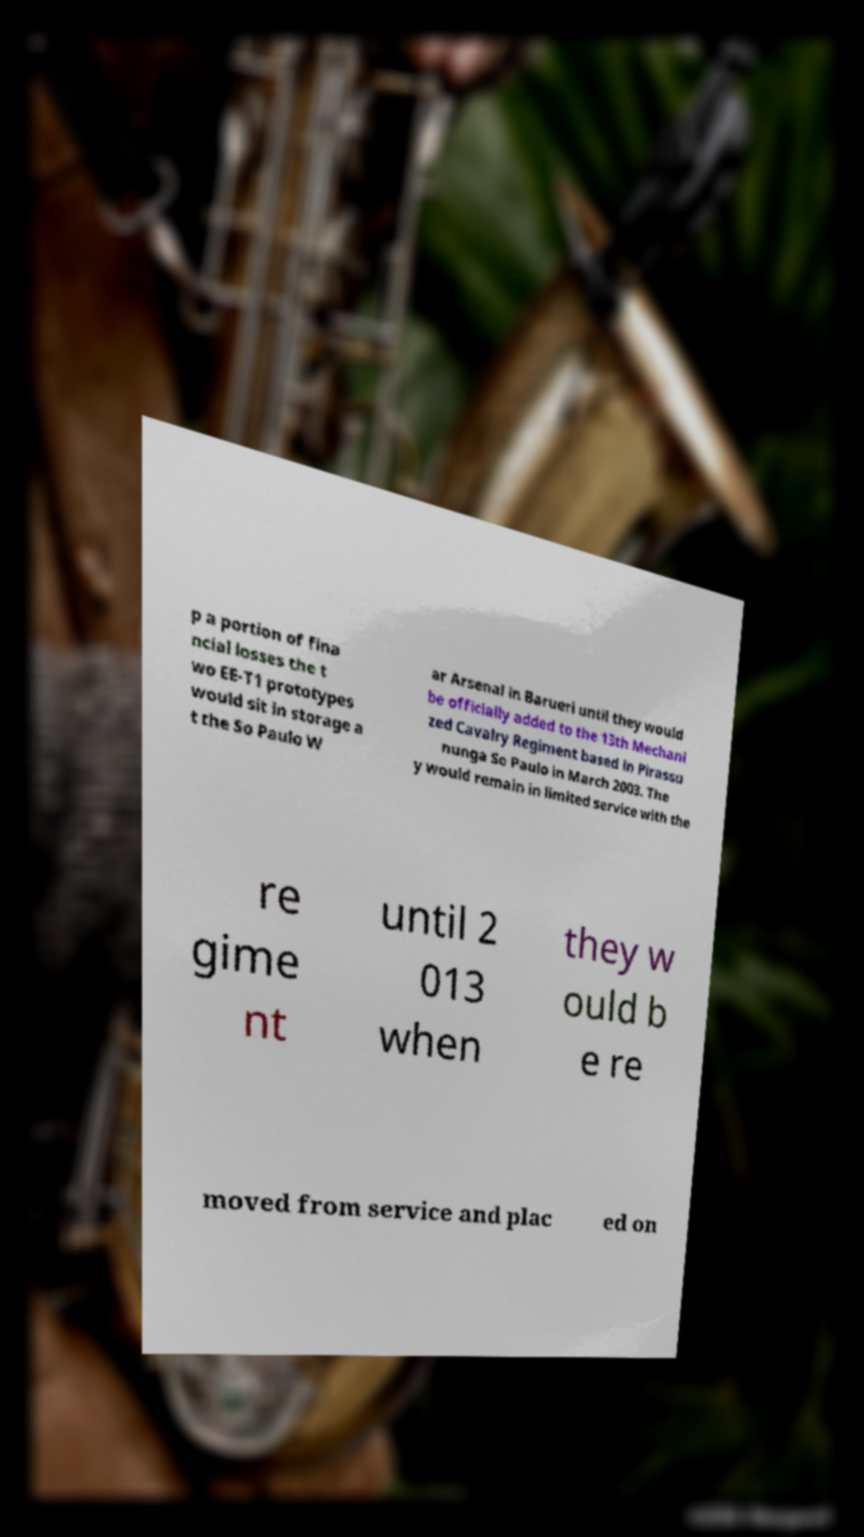I need the written content from this picture converted into text. Can you do that? p a portion of fina ncial losses the t wo EE-T1 prototypes would sit in storage a t the So Paulo W ar Arsenal in Barueri until they would be officially added to the 13th Mechani zed Cavalry Regiment based in Pirassu nunga So Paulo in March 2003. The y would remain in limited service with the re gime nt until 2 013 when they w ould b e re moved from service and plac ed on 